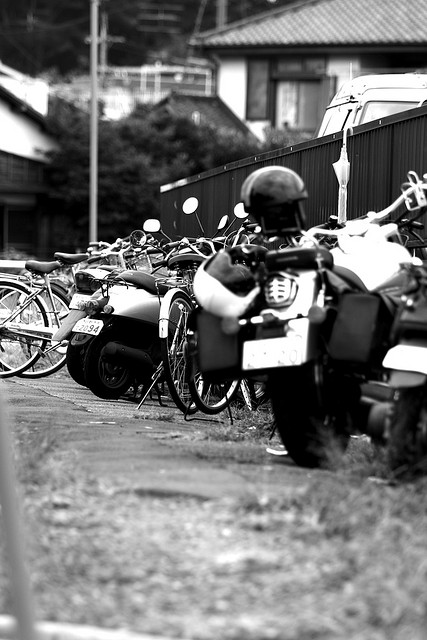Identify and read out the text in this image. 2094 